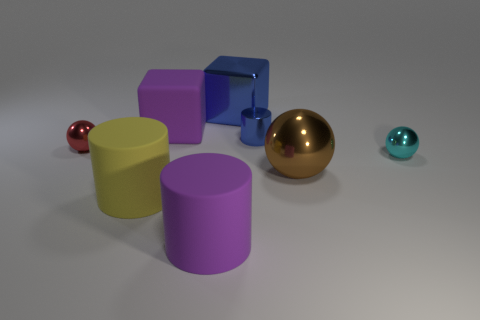Add 2 big balls. How many objects exist? 10 Subtract all balls. How many objects are left? 5 Add 4 large metal objects. How many large metal objects exist? 6 Subtract 1 purple cylinders. How many objects are left? 7 Subtract all blue objects. Subtract all cyan metal things. How many objects are left? 5 Add 7 red objects. How many red objects are left? 8 